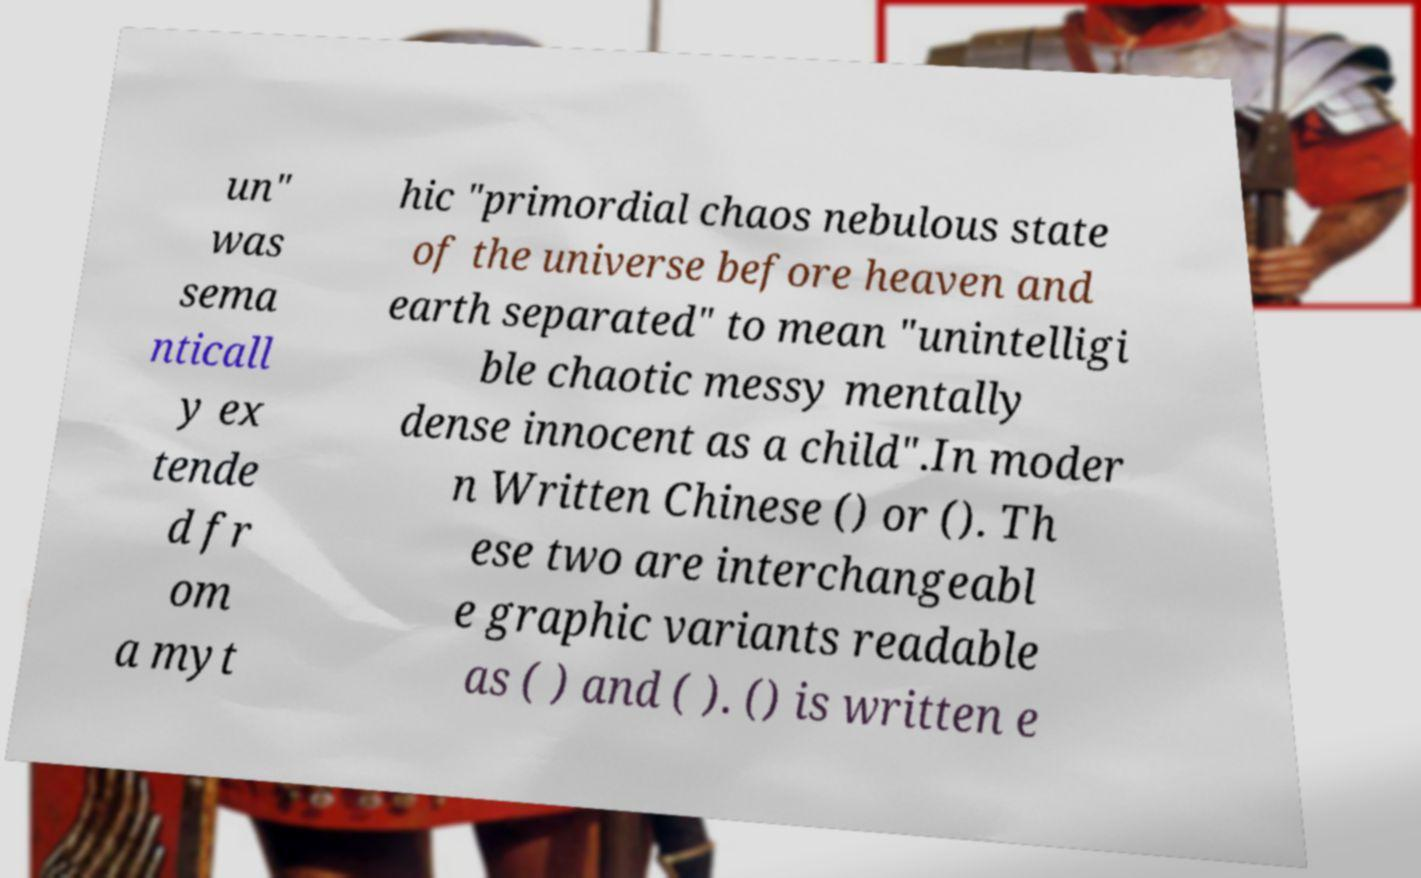Could you extract and type out the text from this image? un" was sema nticall y ex tende d fr om a myt hic "primordial chaos nebulous state of the universe before heaven and earth separated" to mean "unintelligi ble chaotic messy mentally dense innocent as a child".In moder n Written Chinese () or (). Th ese two are interchangeabl e graphic variants readable as ( ) and ( ). () is written e 